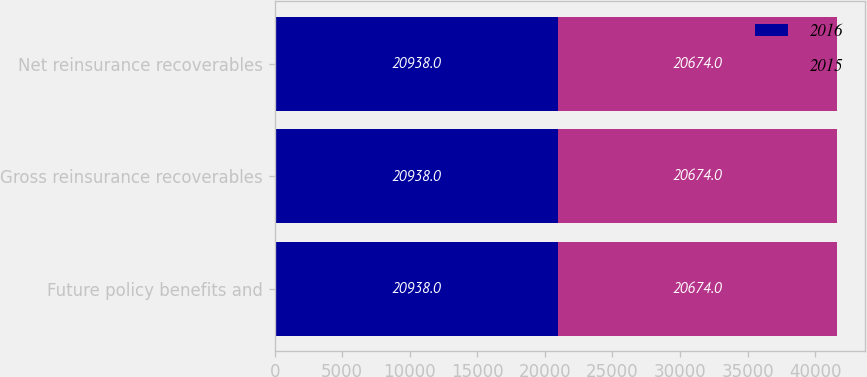<chart> <loc_0><loc_0><loc_500><loc_500><stacked_bar_chart><ecel><fcel>Future policy benefits and<fcel>Gross reinsurance recoverables<fcel>Net reinsurance recoverables<nl><fcel>2016<fcel>20938<fcel>20938<fcel>20938<nl><fcel>2015<fcel>20674<fcel>20674<fcel>20674<nl></chart> 